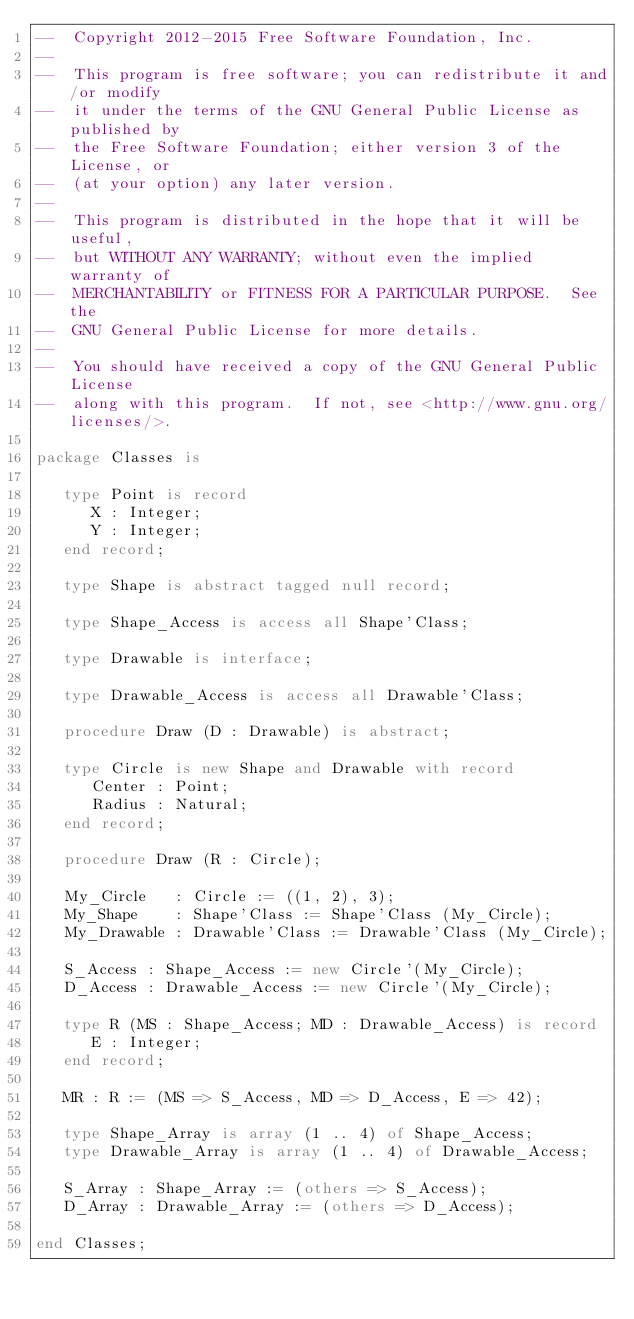<code> <loc_0><loc_0><loc_500><loc_500><_Ada_>--  Copyright 2012-2015 Free Software Foundation, Inc.
--
--  This program is free software; you can redistribute it and/or modify
--  it under the terms of the GNU General Public License as published by
--  the Free Software Foundation; either version 3 of the License, or
--  (at your option) any later version.
--
--  This program is distributed in the hope that it will be useful,
--  but WITHOUT ANY WARRANTY; without even the implied warranty of
--  MERCHANTABILITY or FITNESS FOR A PARTICULAR PURPOSE.  See the
--  GNU General Public License for more details.
--
--  You should have received a copy of the GNU General Public License
--  along with this program.  If not, see <http://www.gnu.org/licenses/>.

package Classes is

   type Point is record
      X : Integer;
      Y : Integer;
   end record;

   type Shape is abstract tagged null record;

   type Shape_Access is access all Shape'Class;

   type Drawable is interface;

   type Drawable_Access is access all Drawable'Class;

   procedure Draw (D : Drawable) is abstract;

   type Circle is new Shape and Drawable with record
      Center : Point;
      Radius : Natural;
   end record;

   procedure Draw (R : Circle);

   My_Circle   : Circle := ((1, 2), 3);
   My_Shape    : Shape'Class := Shape'Class (My_Circle);
   My_Drawable : Drawable'Class := Drawable'Class (My_Circle);

   S_Access : Shape_Access := new Circle'(My_Circle);
   D_Access : Drawable_Access := new Circle'(My_Circle);

   type R (MS : Shape_Access; MD : Drawable_Access) is record
      E : Integer;
   end record;

   MR : R := (MS => S_Access, MD => D_Access, E => 42);

   type Shape_Array is array (1 .. 4) of Shape_Access;
   type Drawable_Array is array (1 .. 4) of Drawable_Access;

   S_Array : Shape_Array := (others => S_Access);
   D_Array : Drawable_Array := (others => D_Access);

end Classes;
</code> 